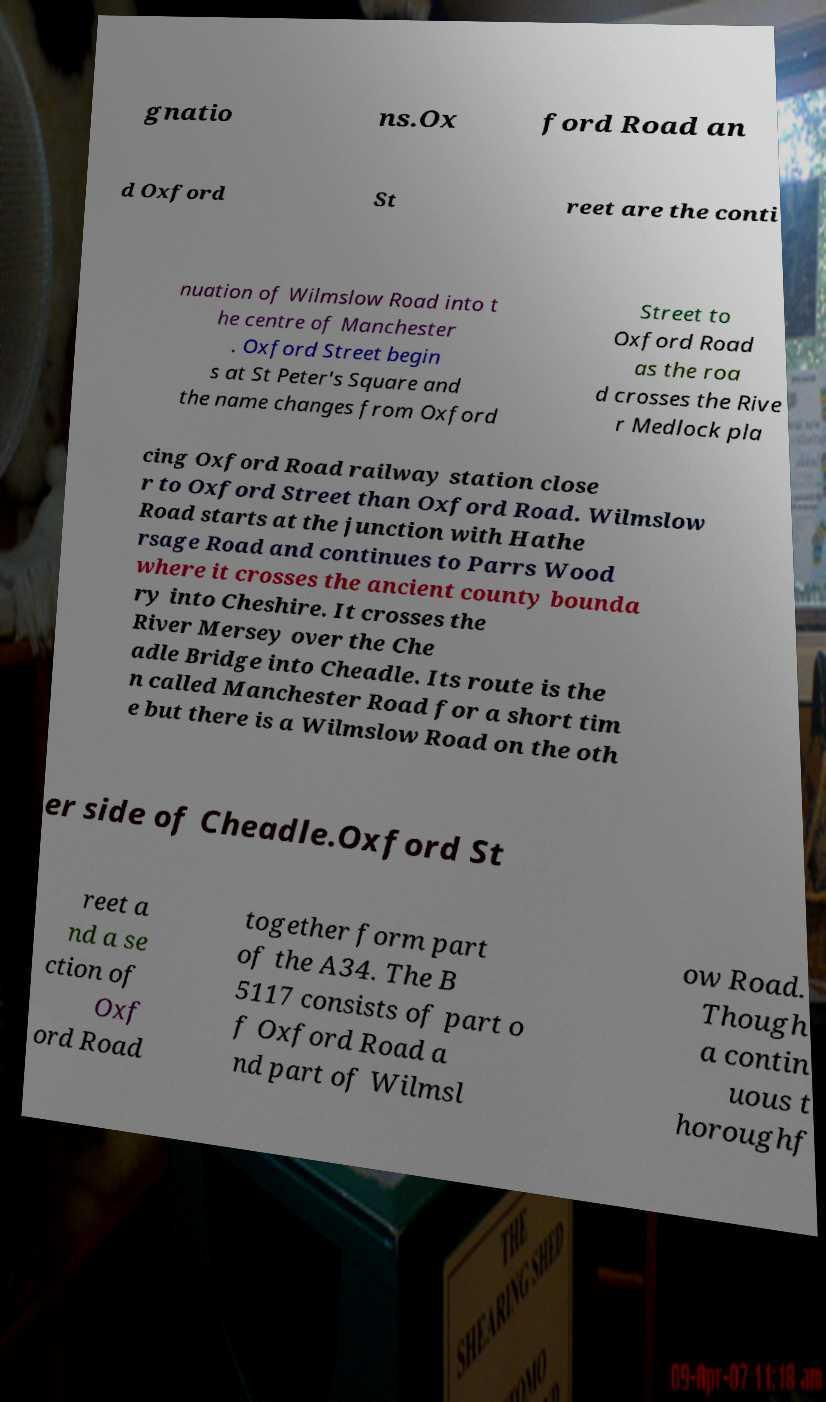Please read and relay the text visible in this image. What does it say? gnatio ns.Ox ford Road an d Oxford St reet are the conti nuation of Wilmslow Road into t he centre of Manchester . Oxford Street begin s at St Peter's Square and the name changes from Oxford Street to Oxford Road as the roa d crosses the Rive r Medlock pla cing Oxford Road railway station close r to Oxford Street than Oxford Road. Wilmslow Road starts at the junction with Hathe rsage Road and continues to Parrs Wood where it crosses the ancient county bounda ry into Cheshire. It crosses the River Mersey over the Che adle Bridge into Cheadle. Its route is the n called Manchester Road for a short tim e but there is a Wilmslow Road on the oth er side of Cheadle.Oxford St reet a nd a se ction of Oxf ord Road together form part of the A34. The B 5117 consists of part o f Oxford Road a nd part of Wilmsl ow Road. Though a contin uous t horoughf 